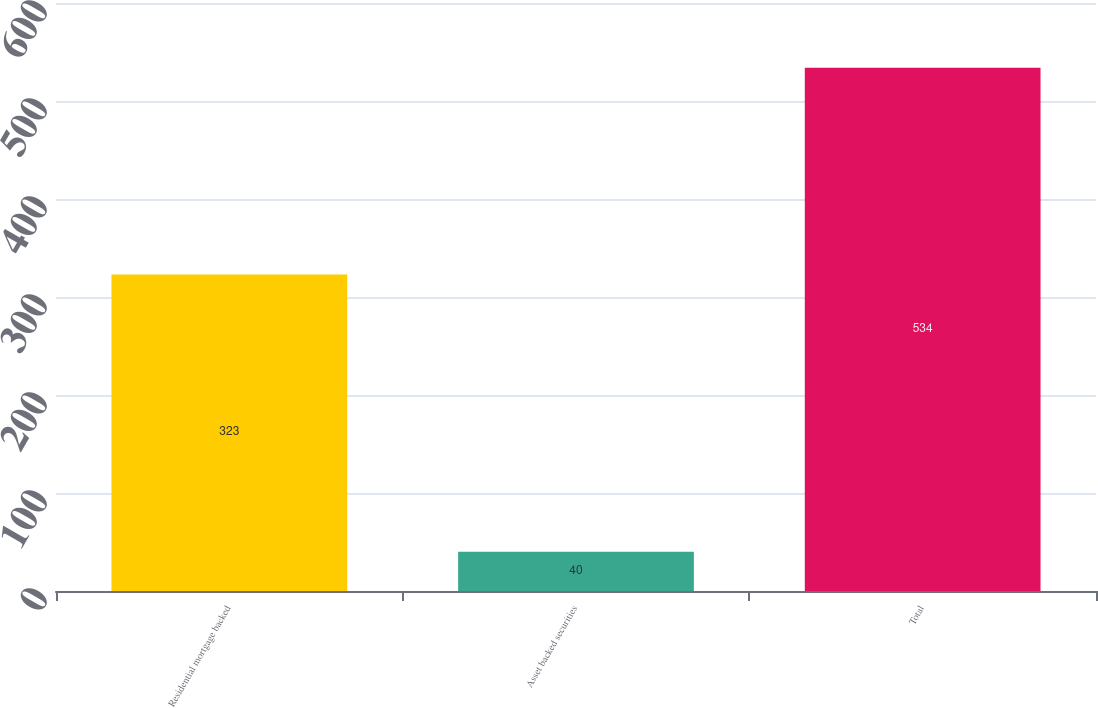<chart> <loc_0><loc_0><loc_500><loc_500><bar_chart><fcel>Residential mortgage backed<fcel>Asset backed securities<fcel>Total<nl><fcel>323<fcel>40<fcel>534<nl></chart> 